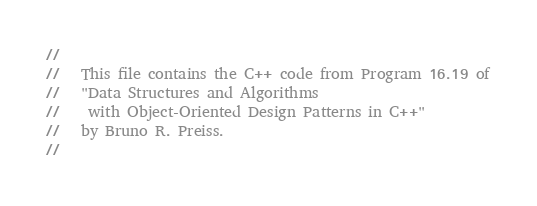Convert code to text. <code><loc_0><loc_0><loc_500><loc_500><_C++_>//
//   This file contains the C++ code from Program 16.19 of
//   "Data Structures and Algorithms
//    with Object-Oriented Design Patterns in C++"
//   by Bruno R. Preiss.
//</code> 